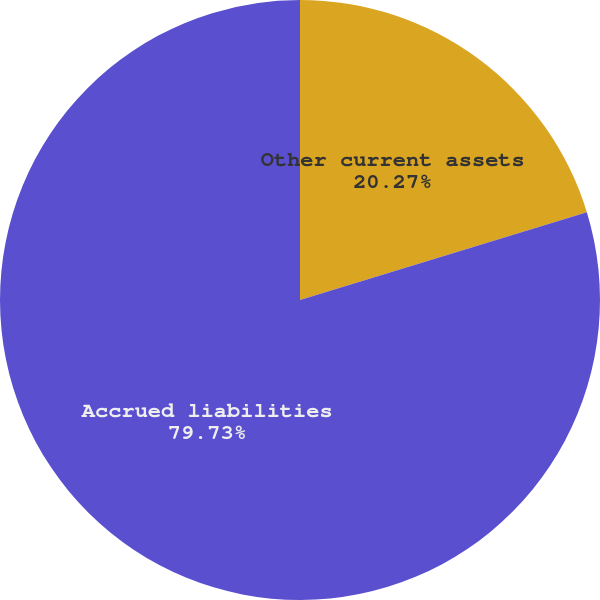Convert chart. <chart><loc_0><loc_0><loc_500><loc_500><pie_chart><fcel>Other current assets<fcel>Accrued liabilities<nl><fcel>20.27%<fcel>79.73%<nl></chart> 